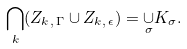<formula> <loc_0><loc_0><loc_500><loc_500>\underset { k } { \bigcap } ( Z _ { k , \, \Gamma } \cup Z _ { k , \, \epsilon } ) = \underset { \sigma } \cup K _ { \sigma } .</formula> 